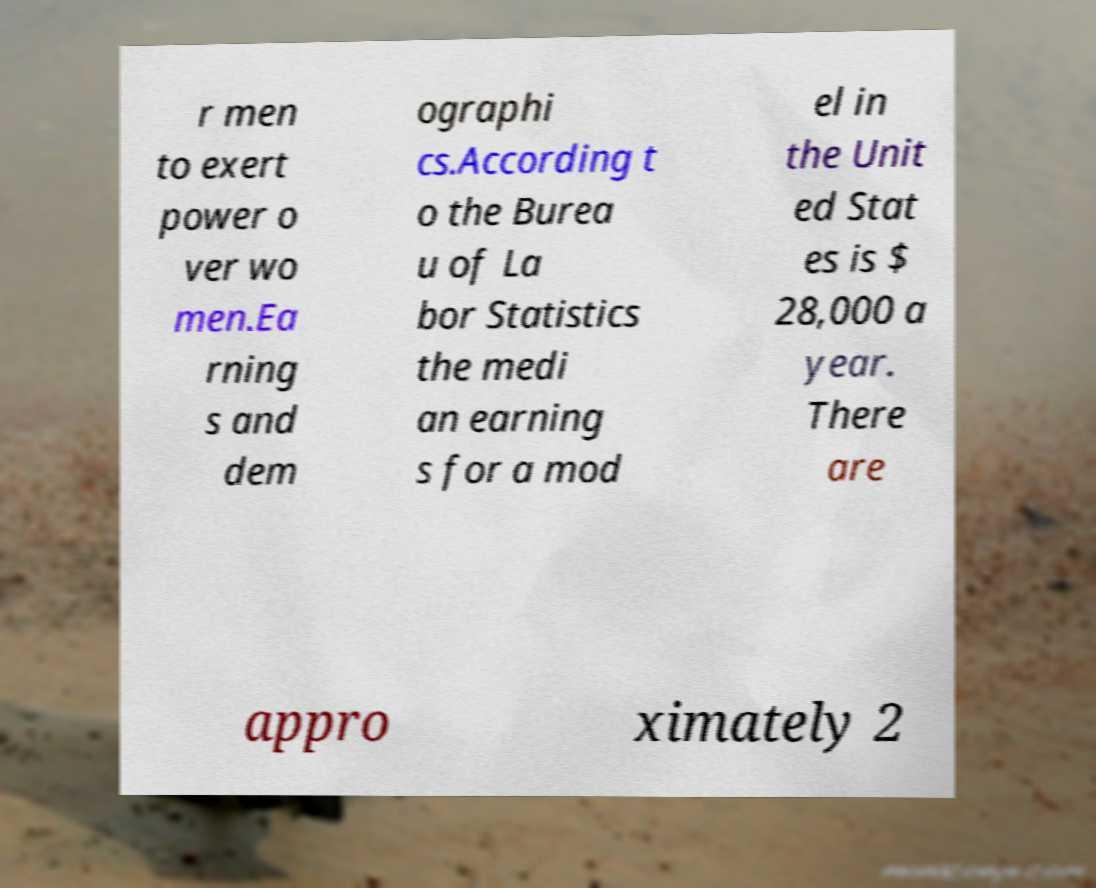Can you accurately transcribe the text from the provided image for me? r men to exert power o ver wo men.Ea rning s and dem ographi cs.According t o the Burea u of La bor Statistics the medi an earning s for a mod el in the Unit ed Stat es is $ 28,000 a year. There are appro ximately 2 